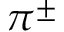<formula> <loc_0><loc_0><loc_500><loc_500>\pi ^ { \pm }</formula> 